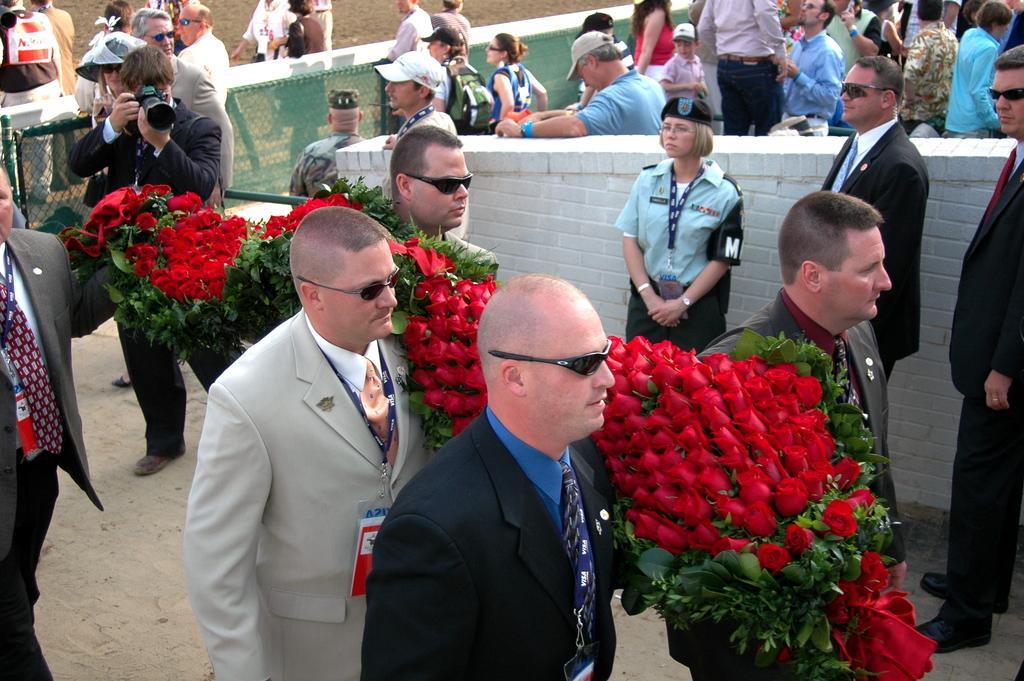Could you give a brief overview of what you see in this image? In this image we can see people holding flowers. In the background of the image there are people standing. There is a person holding a camera. There is fencing. At the bottom of the image there is sand. 